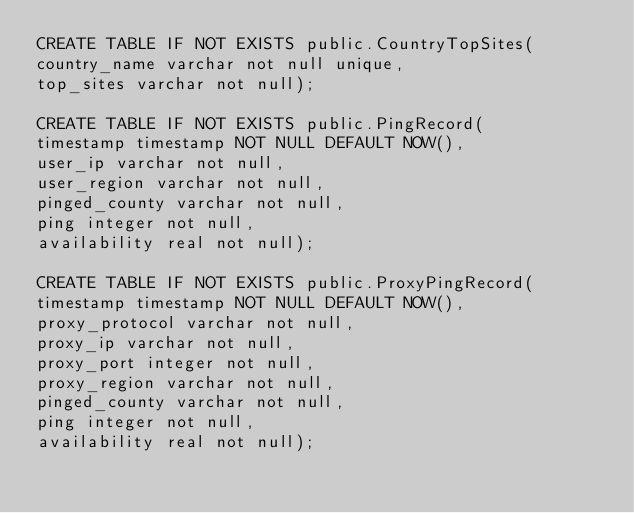<code> <loc_0><loc_0><loc_500><loc_500><_SQL_>CREATE TABLE IF NOT EXISTS public.CountryTopSites(
country_name varchar not null unique,
top_sites varchar not null);

CREATE TABLE IF NOT EXISTS public.PingRecord(
timestamp timestamp NOT NULL DEFAULT NOW(),
user_ip varchar not null,
user_region varchar not null,
pinged_county varchar not null,
ping integer not null,
availability real not null);

CREATE TABLE IF NOT EXISTS public.ProxyPingRecord(
timestamp timestamp NOT NULL DEFAULT NOW(),
proxy_protocol varchar not null,
proxy_ip varchar not null,
proxy_port integer not null,
proxy_region varchar not null,
pinged_county varchar not null,
ping integer not null,
availability real not null);

</code> 